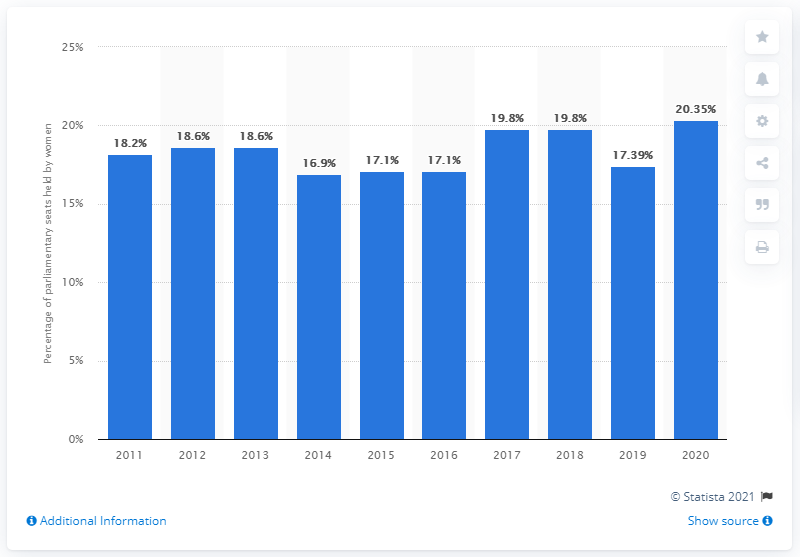List a handful of essential elements in this visual. In 2019, the proportion of women in ministerial positions in Indonesia decreased. 